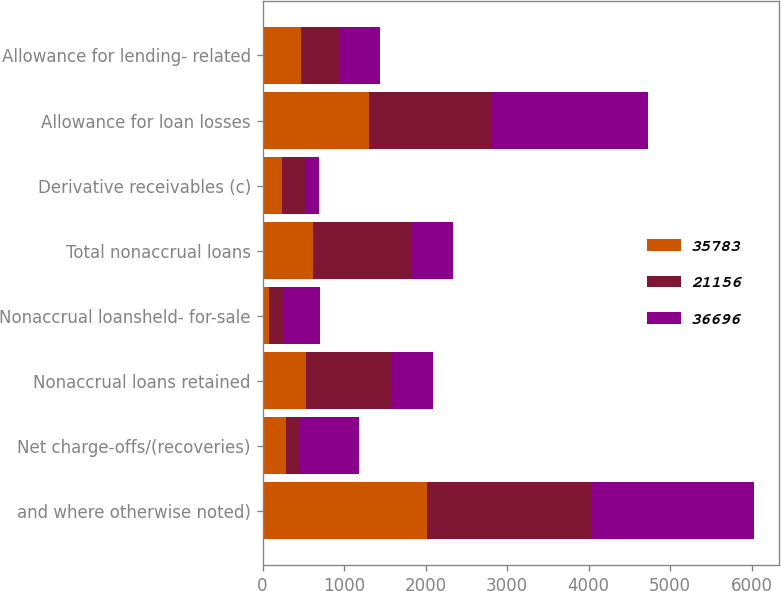<chart> <loc_0><loc_0><loc_500><loc_500><stacked_bar_chart><ecel><fcel>and where otherwise noted)<fcel>Net charge-offs/(recoveries)<fcel>Nonaccrual loans retained<fcel>Nonaccrual loansheld- for-sale<fcel>Total nonaccrual loans<fcel>Derivative receivables (c)<fcel>Allowance for loan losses<fcel>Allowance for lending- related<nl><fcel>35783<fcel>2012<fcel>284<fcel>535<fcel>82<fcel>617<fcel>239<fcel>1300<fcel>473<nl><fcel>21156<fcel>2011<fcel>161<fcel>1039<fcel>166<fcel>1205<fcel>293<fcel>1501<fcel>467<nl><fcel>36696<fcel>2010<fcel>736<fcel>516.5<fcel>460<fcel>516.5<fcel>159<fcel>1928<fcel>498<nl></chart> 